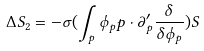<formula> <loc_0><loc_0><loc_500><loc_500>\Delta S _ { 2 } = - \sigma ( \int _ { p } \phi _ { p } p \cdot \partial _ { p } ^ { \prime } \frac { \delta } { \delta \phi _ { p } } ) S</formula> 